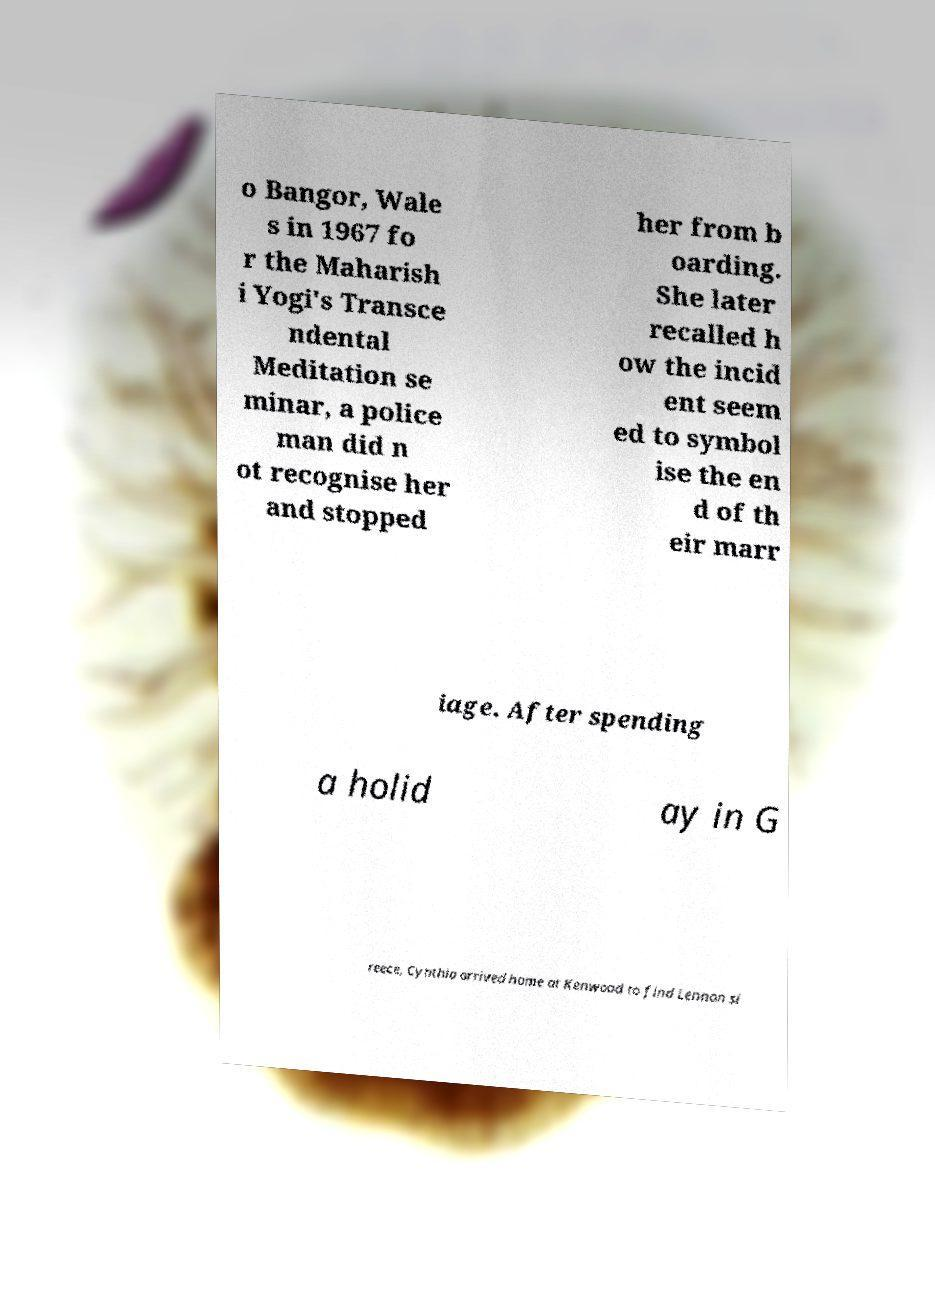There's text embedded in this image that I need extracted. Can you transcribe it verbatim? o Bangor, Wale s in 1967 fo r the Maharish i Yogi's Transce ndental Meditation se minar, a police man did n ot recognise her and stopped her from b oarding. She later recalled h ow the incid ent seem ed to symbol ise the en d of th eir marr iage. After spending a holid ay in G reece, Cynthia arrived home at Kenwood to find Lennon si 